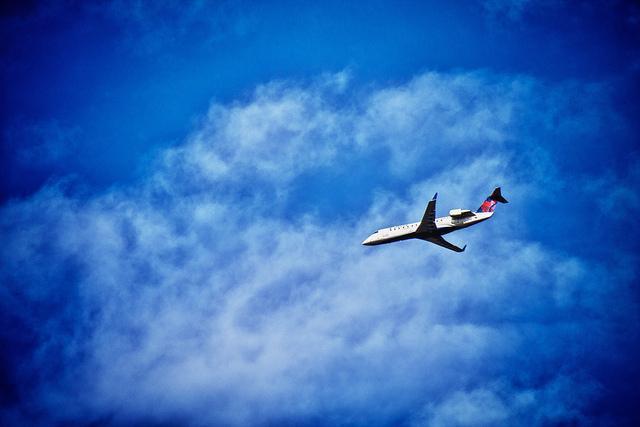How many engines does the plane have?
Give a very brief answer. 2. 